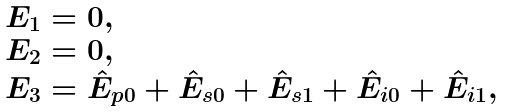Convert formula to latex. <formula><loc_0><loc_0><loc_500><loc_500>\begin{array} { l } E _ { 1 } = 0 , \\ E _ { 2 } = 0 , \\ E _ { 3 } = \hat { E } _ { p 0 } + \hat { E } _ { s 0 } + \hat { E } _ { s 1 } + \hat { E } _ { i 0 } + \hat { E } _ { i 1 } , \end{array}</formula> 